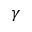Convert formula to latex. <formula><loc_0><loc_0><loc_500><loc_500>\gamma</formula> 